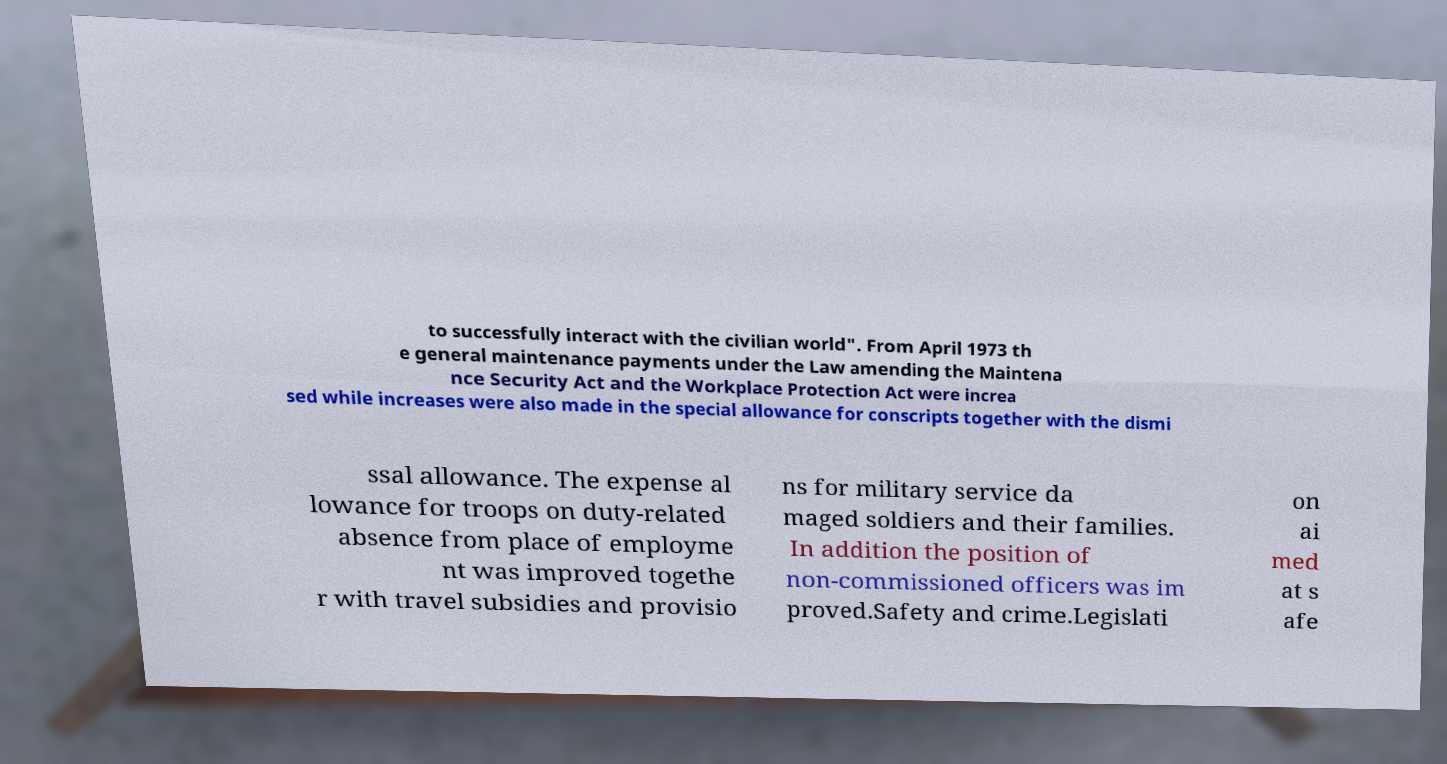Can you read and provide the text displayed in the image?This photo seems to have some interesting text. Can you extract and type it out for me? to successfully interact with the civilian world". From April 1973 th e general maintenance payments under the Law amending the Maintena nce Security Act and the Workplace Protection Act were increa sed while increases were also made in the special allowance for conscripts together with the dismi ssal allowance. The expense al lowance for troops on duty-related absence from place of employme nt was improved togethe r with travel subsidies and provisio ns for military service da maged soldiers and their families. In addition the position of non-commissioned officers was im proved.Safety and crime.Legislati on ai med at s afe 